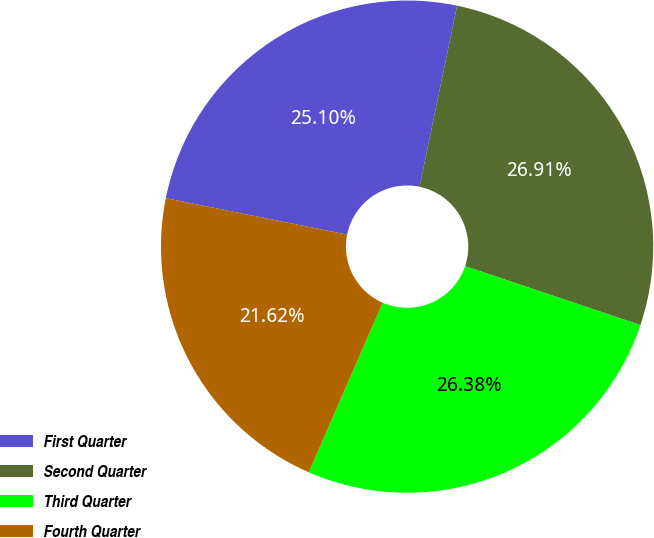Convert chart to OTSL. <chart><loc_0><loc_0><loc_500><loc_500><pie_chart><fcel>First Quarter<fcel>Second Quarter<fcel>Third Quarter<fcel>Fourth Quarter<nl><fcel>25.1%<fcel>26.91%<fcel>26.38%<fcel>21.62%<nl></chart> 